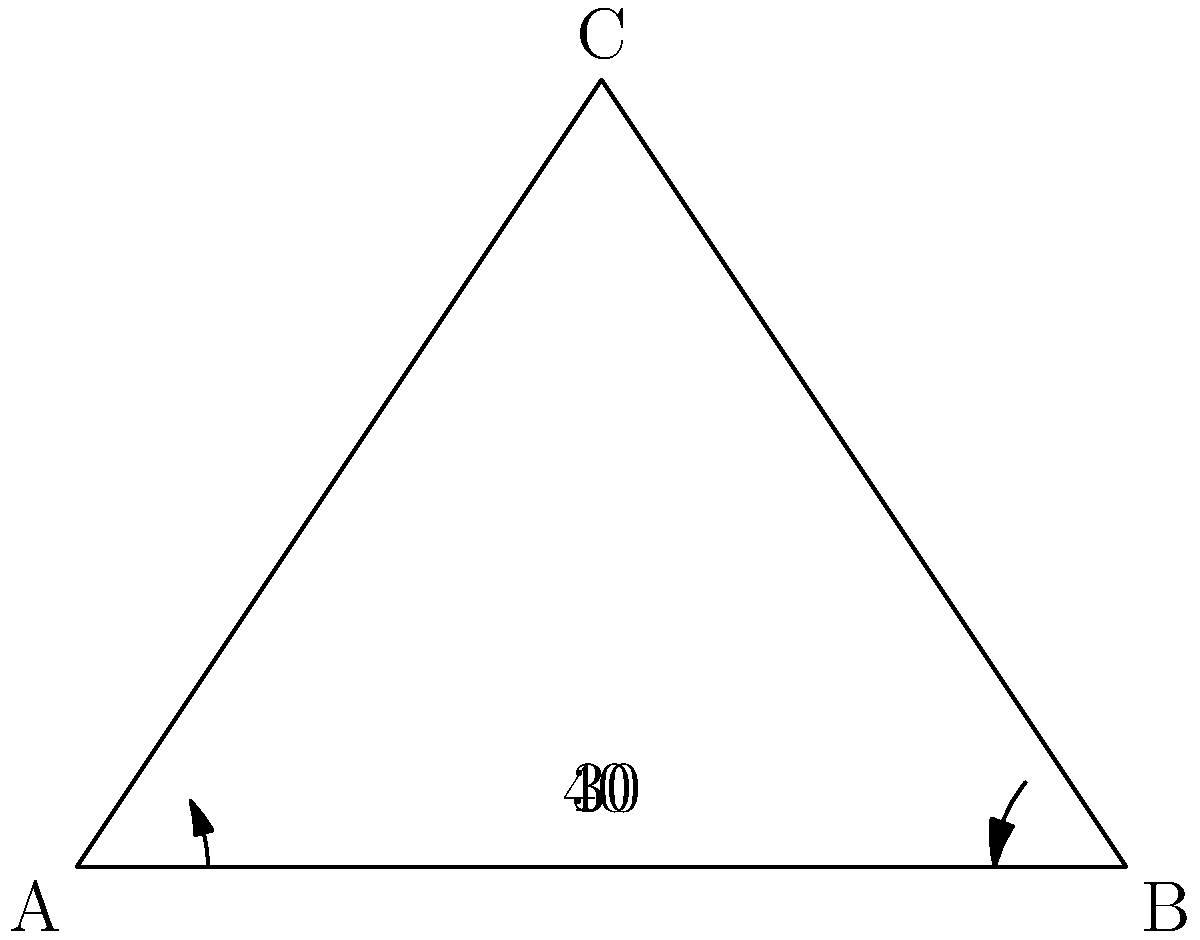As a television advertising expert branching into digital media promotion, you're tasked with optimizing the placement of two digital billboards. The billboards are represented by sides AC and BC of a triangle ABC. Given that the angle between the ground (AB) and billboard AC is 30°, and the angle between the ground and billboard BC is 40°, what is the angle between the two billboards for optimal viewer attention? To solve this problem, we'll follow these steps:

1) First, we need to recognize that the angle between the billboards is the same as the angle at vertex C of the triangle.

2) In a triangle, the sum of all angles is always 180°. We can use this property to find the angle at C.

3) Let's define the angles:
   - Angle at A (between ground and AC) = 30°
   - Angle at B (between ground and BC) = 40°
   - Angle at C (between the billboards) = x° (what we're solving for)

4) Using the triangle angle sum property:
   $$30° + 40° + x° = 180°$$

5) Simplify:
   $$70° + x° = 180°$$

6) Solve for x:
   $$x° = 180° - 70° = 110°$$

Therefore, the angle between the two billboards for optimal viewer attention is 110°.
Answer: 110° 